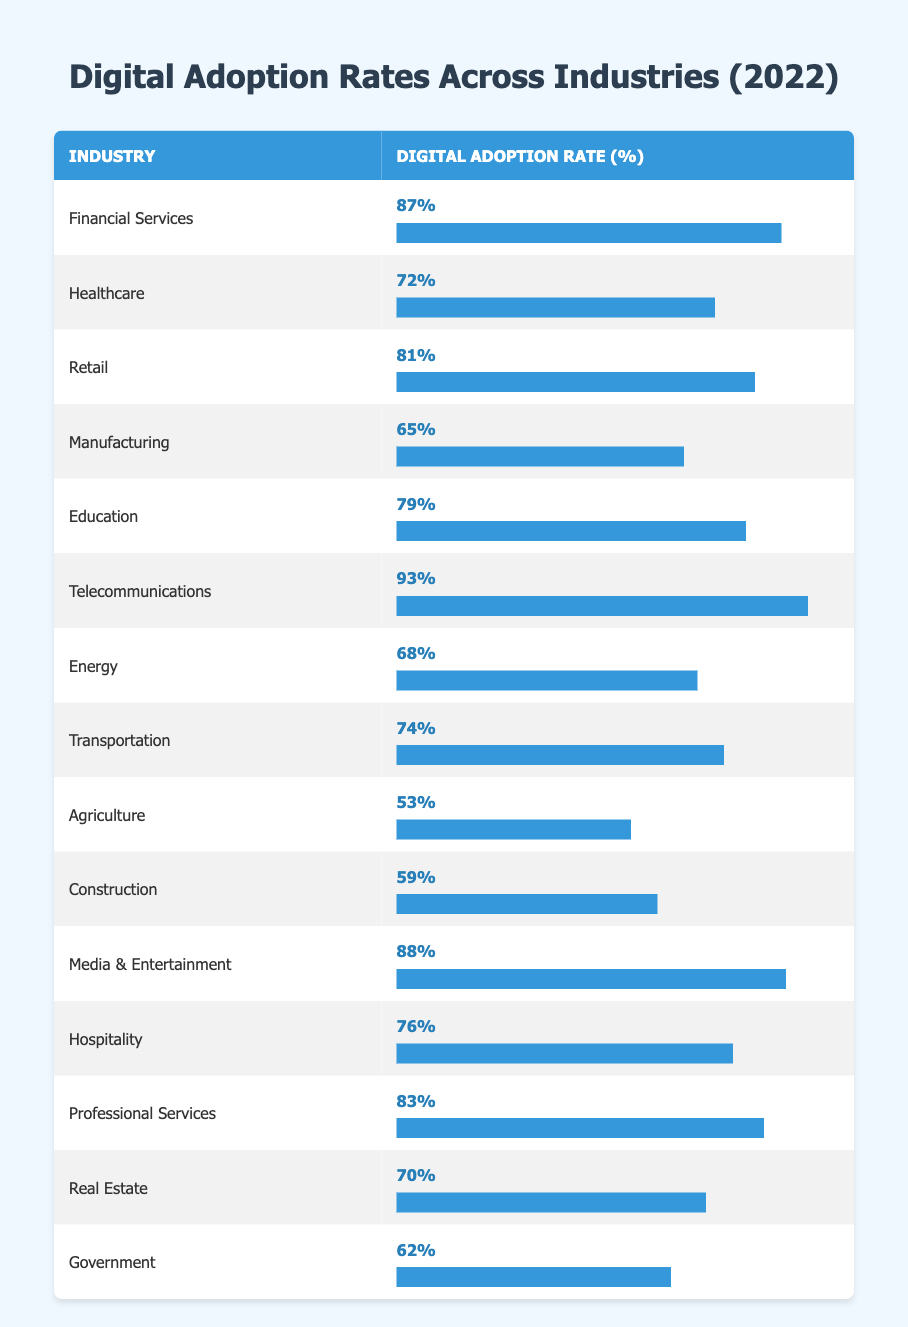What is the digital adoption rate for telecommunications? The table directly lists the digital adoption rate for telecommunications as 93%.
Answer: 93% Which industry has the lowest digital adoption rate? By inspecting the adoption rates, agriculture has the lowest rate at 53%.
Answer: Agriculture What is the average digital adoption rate across all industries in the table? Calculate the sum of all digital adoption rates: (87 + 72 + 81 + 65 + 79 + 93 + 68 + 74 + 53 + 59 + 88 + 76 + 83 + 70 + 62) = 1111. There are 15 industries, so the average is 1111/15 ≈ 74.07.
Answer: Approximately 74.07 Is the digital adoption rate in healthcare higher than that in government? The digital adoption rate for healthcare is 72%, while for government it is 62%. 72% is indeed higher than 62%.
Answer: Yes Which two industries have a digital adoption rate of 80% or higher? Looking at the table, the industries with 80% or higher adoption rates are financial services (87%) and telecommunications (93%).
Answer: Financial Services, Telecommunications How many industries have a digital adoption rate below 60%? From the table, agriculture (53%) and construction (59%) are the only two industries below 60%. Hence, there are 2 such industries.
Answer: 2 What is the difference in digital adoption rates between financial services and transportation? Financial services have a rate of 87% and transportation has a rate of 74%. The difference is 87% - 74% = 13%.
Answer: 13% Which industry has a digital adoption rate closest to the average calculated previously? The average digital adoption rate is approximately 74.07%. Transportation's rate at 74% is closest to this average.
Answer: Transportation 